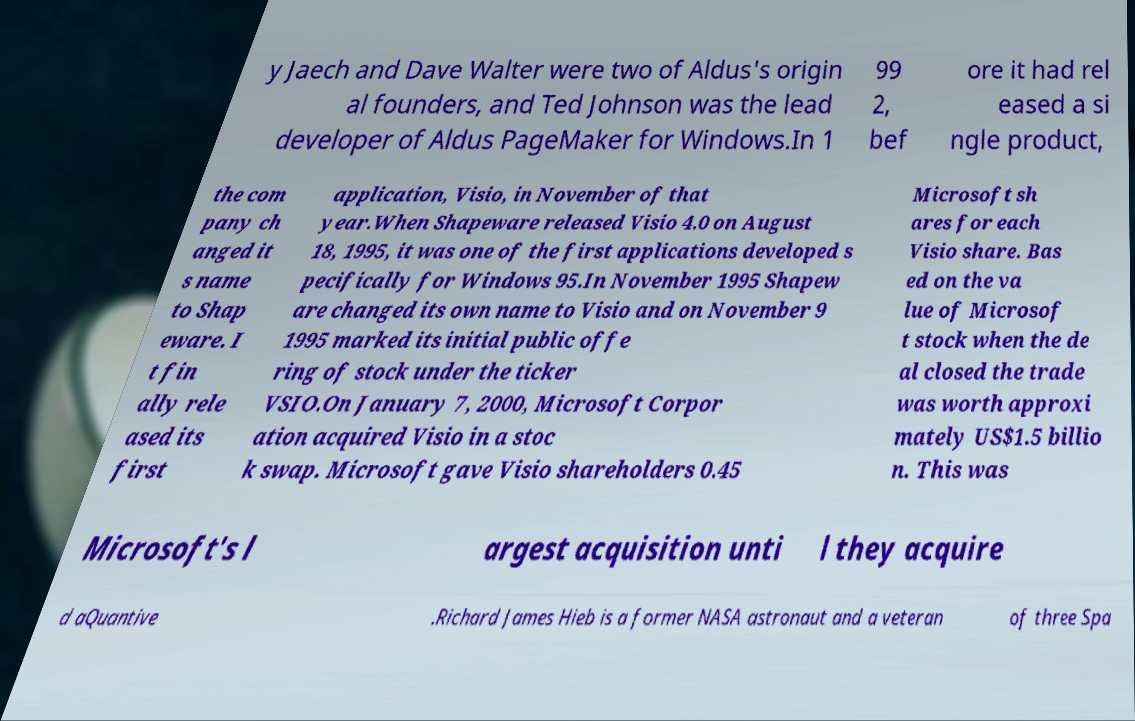Could you assist in decoding the text presented in this image and type it out clearly? y Jaech and Dave Walter were two of Aldus's origin al founders, and Ted Johnson was the lead developer of Aldus PageMaker for Windows.In 1 99 2, bef ore it had rel eased a si ngle product, the com pany ch anged it s name to Shap eware. I t fin ally rele ased its first application, Visio, in November of that year.When Shapeware released Visio 4.0 on August 18, 1995, it was one of the first applications developed s pecifically for Windows 95.In November 1995 Shapew are changed its own name to Visio and on November 9 1995 marked its initial public offe ring of stock under the ticker VSIO.On January 7, 2000, Microsoft Corpor ation acquired Visio in a stoc k swap. Microsoft gave Visio shareholders 0.45 Microsoft sh ares for each Visio share. Bas ed on the va lue of Microsof t stock when the de al closed the trade was worth approxi mately US$1.5 billio n. This was Microsoft's l argest acquisition unti l they acquire d aQuantive .Richard James Hieb is a former NASA astronaut and a veteran of three Spa 